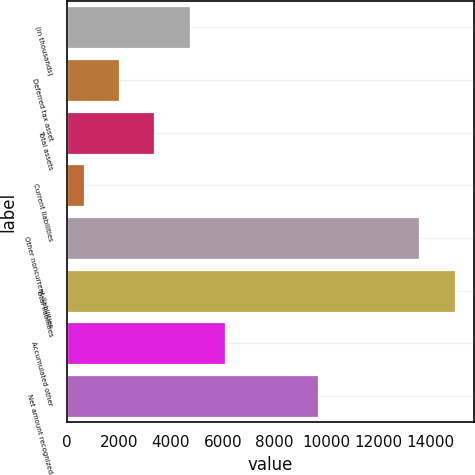Convert chart to OTSL. <chart><loc_0><loc_0><loc_500><loc_500><bar_chart><fcel>(in thousands)<fcel>Deferred tax asset<fcel>Total assets<fcel>Current liabilities<fcel>Other noncurrent liabilities<fcel>Total liabilities<fcel>Accumulated other<fcel>Net amount recognized<nl><fcel>4723.2<fcel>2010.4<fcel>3366.8<fcel>654<fcel>13564<fcel>14920.4<fcel>6079.6<fcel>9649<nl></chart> 